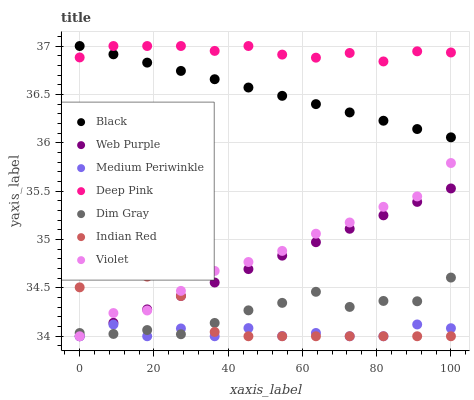Does Medium Periwinkle have the minimum area under the curve?
Answer yes or no. Yes. Does Deep Pink have the maximum area under the curve?
Answer yes or no. Yes. Does Web Purple have the minimum area under the curve?
Answer yes or no. No. Does Web Purple have the maximum area under the curve?
Answer yes or no. No. Is Web Purple the smoothest?
Answer yes or no. Yes. Is Medium Periwinkle the roughest?
Answer yes or no. Yes. Is Medium Periwinkle the smoothest?
Answer yes or no. No. Is Web Purple the roughest?
Answer yes or no. No. Does Medium Periwinkle have the lowest value?
Answer yes or no. Yes. Does Dim Gray have the lowest value?
Answer yes or no. No. Does Black have the highest value?
Answer yes or no. Yes. Does Web Purple have the highest value?
Answer yes or no. No. Is Indian Red less than Deep Pink?
Answer yes or no. Yes. Is Black greater than Web Purple?
Answer yes or no. Yes. Does Indian Red intersect Dim Gray?
Answer yes or no. Yes. Is Indian Red less than Dim Gray?
Answer yes or no. No. Is Indian Red greater than Dim Gray?
Answer yes or no. No. Does Indian Red intersect Deep Pink?
Answer yes or no. No. 